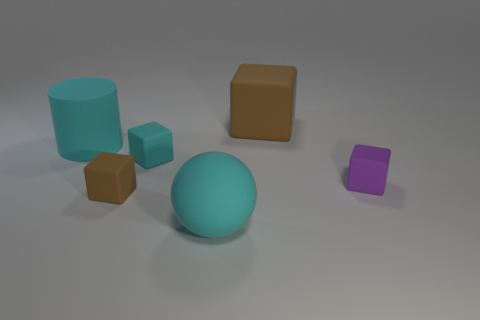There is a matte object that is both in front of the large cyan cylinder and right of the big cyan matte ball; what color is it?
Your answer should be very brief. Purple. The purple thing that is the same size as the cyan matte block is what shape?
Provide a short and direct response. Cube. Is there another large brown thing that has the same shape as the big brown object?
Give a very brief answer. No. Are the tiny purple object and the big cyan object in front of the cylinder made of the same material?
Provide a succinct answer. Yes. There is a big matte thing on the left side of the brown block in front of the brown cube that is behind the small brown block; what color is it?
Provide a succinct answer. Cyan. What is the material of the cyan thing that is the same size as the cylinder?
Give a very brief answer. Rubber. What number of other big brown cubes are made of the same material as the large brown block?
Your answer should be compact. 0. Does the cyan rubber thing that is in front of the purple cube have the same size as the cube behind the big cyan cylinder?
Ensure brevity in your answer.  Yes. What is the color of the rubber cylinder left of the large brown object?
Your response must be concise. Cyan. There is a large cylinder that is the same color as the big sphere; what is its material?
Make the answer very short. Rubber. 